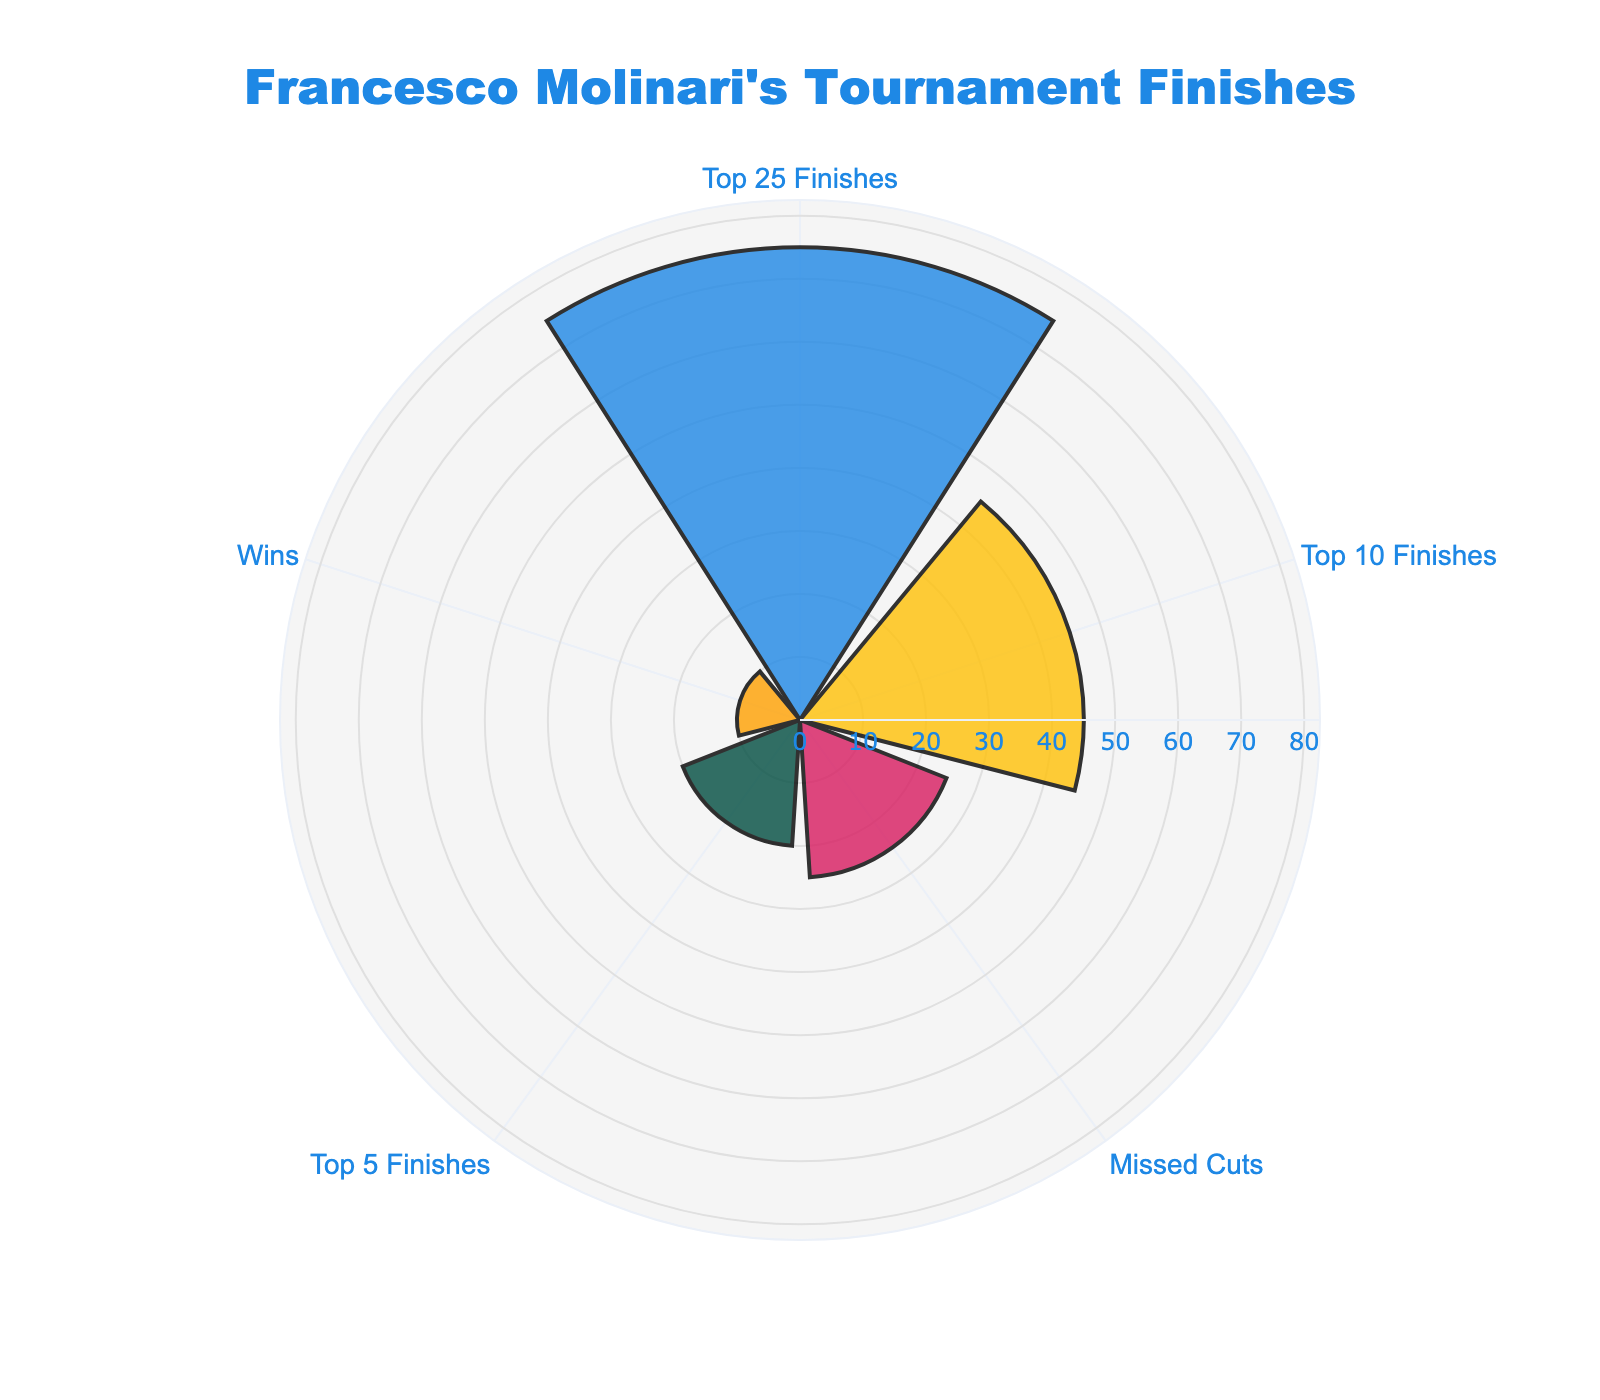What's the title of the chart? The title of the chart is situated at the top, center of the figure. It reads "Francesco Molinari's Tournament Finishes".
Answer: Francesco Molinari's Tournament Finishes What is the category with the highest count? Observe the rose chart; the largest radial distance corresponds to "Top 25 Finishes" at 75.
Answer: Top 25 Finishes How many wins does Francesco Molinari have? Look at the category labeled "Wins" on the chart and see the radial distance. The annotation says 10.
Answer: 10 Which category has fewer finishes: "Missed Cuts" or "Top 10 Finishes"? Compare the radial lengths of "Missed Cuts" and "Top 10 Finishes". "Missed Cuts" has a count of 25, while "Top 10 Finishes" has a count of 45.
Answer: Missed Cuts What is the total number of tournament finishes in categories "Top 10 Finishes" and "Top 5 Finishes"? Sum the counts for "Top 10 Finishes" and "Top 5 Finishes": 45 + 20 = 65.
Answer: 65 Which category has the smallest number of finishes? Check the radial distances for each category. The shortest one is "Wins" with 10.
Answer: Wins How much greater is the number of "Top 25 Finishes" compared to "Missed Cuts"? Subtract the count of "Missed Cuts" from "Top 25 Finishes": 75 - 25 = 50.
Answer: 50 What percentage of Francesco Molinari's finishes are "Top 5 Finishes"? Calculate the total finishes: 45 + 75 + 25 + 20 + 10 = 175. The percentage of "Top 5 Finishes" is (20/175) * 100 ≈ 11.43%.
Answer: Approximately 11.43% Is the number of "Top 10 Finishes" closer to the number of "Top 5 Finishes" or "Missed Cuts"? Compare the differences: 45 - 20 = 25 and 45 - 25 = 20. The number of "Top 10 Finishes" is closer to "Missed Cuts."
Answer: Missed Cuts What is the average number of finishes across all categories? The total number of finishes is 175, and there are 5 categories. The average is 175 / 5 = 35.
Answer: 35 